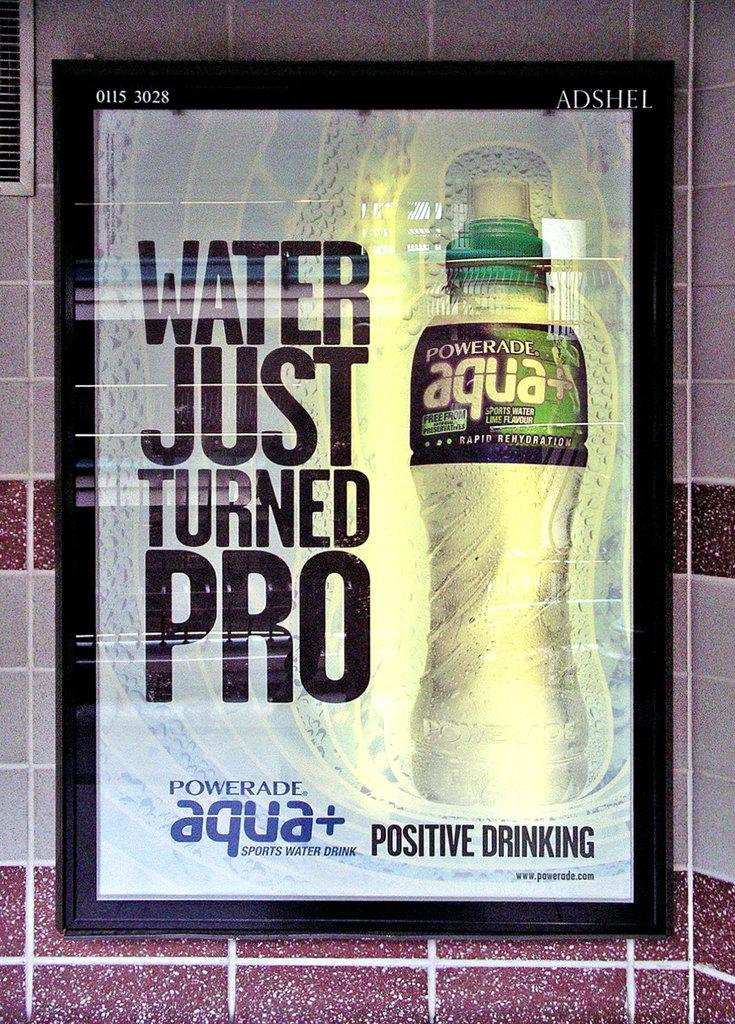Provide a one-sentence caption for the provided image. An advertisement for Powerade Aqua on a title wall. 